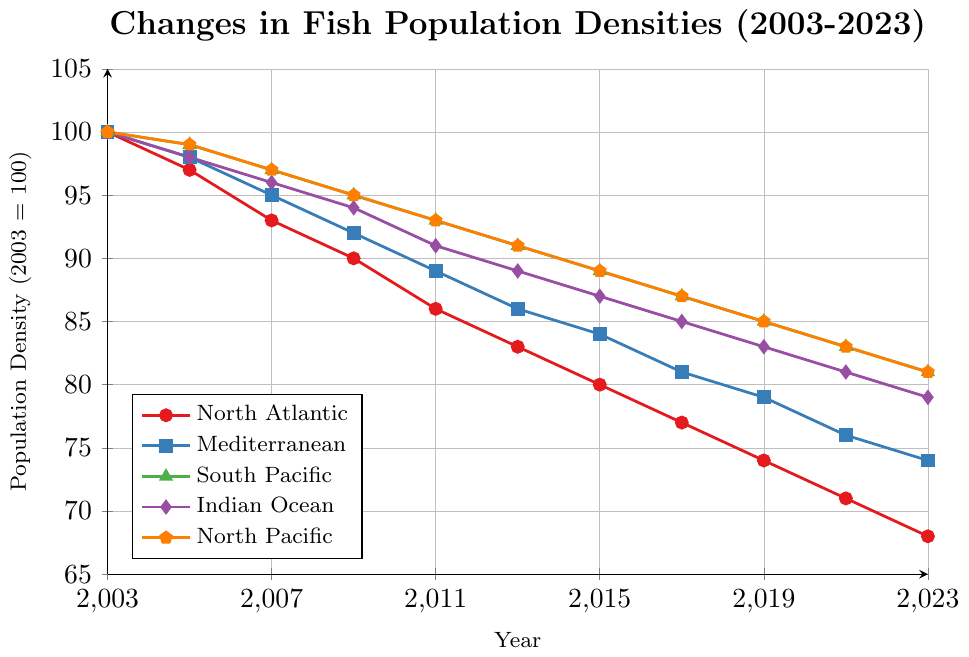What year did the North Atlantic fish population density first fall below 80? According to the North Atlantic line (red with circles), the population density first falls below 80 in the year 2015.
Answer: 2015 Which fishing zone maintained the highest population density in 2023? Inspect the end points of all the lines in the year 2023. The South Pacific (green with triangles) and North Pacific (orange with pentagons) both have a population density of 81, which is the highest in that year.
Answer: South Pacific and North Pacific What's the average population density of the Indian Ocean from 2013 to 2023? Sum the population densities of the Indian Ocean (purple with diamonds) for the years 2013, 2015, 2017, 2019, 2021, and 2023: 89 + 87 + 85 + 83 + 81 + 79 = 504. There are six values, so the average is 504 / 6 = 84.
Answer: 84 Which zone experienced the greatest decline in population density from 2003 to 2023? Calculate the difference between the population densities in 2003 and 2023 for each zone. North Atlantic: 100 - 68 = 32; Mediterranean: 100 - 74 = 26; South Pacific: 100 - 81 = 19; Indian Ocean: 100 - 79 = 21; North Pacific: 100 - 81 = 19. The North Atlantic had the greatest decline of 32.
Answer: North Atlantic In which year did the South Pacific and North Pacific have the same fish population density? Compare the values of the South Pacific and North Pacific lines (green and orange respectively). The densities are the same in 2013 and 2023 both at 91, and 81 respectively.
Answer: 2013 and 2023 How much was the difference in population density between the Indian Ocean and the Mediterranean in 2021? Subtract the population density of the Mediterranean (blue with squares) from the Indian Ocean (purple with diamonds) for the year 2021. Indian Ocean: 81, Mediterranean: 76. The difference is 81 - 76 = 5.
Answer: 5 Which zone had the smallest change in population density from 2003 to 2023? Calculate the change in population density for each zone from 2003 to 2023. North Atlantic: 100 - 68 = 32; Mediterranean: 100 - 74 = 26; South Pacific: 100 - 81 = 19; Indian Ocean: 100 - 79 = 21; North Pacific: 100 - 81 = 19. The South Pacific and North Pacific both had the smallest change of 19.
Answer: South Pacific and North Pacific What color represents the Mediterranean fishing zone? In the legend and the lines, the Mediterranean fishing zone is shown in blue with square markers.
Answer: Blue Between 2005 and 2015, which zone showed the most steady decline in fish population density? By observing the slope of the lines between 2005 and 2015, the North Pacific (orange with pentagons) appears to have a consistent and steady decline.
Answer: North Pacific 